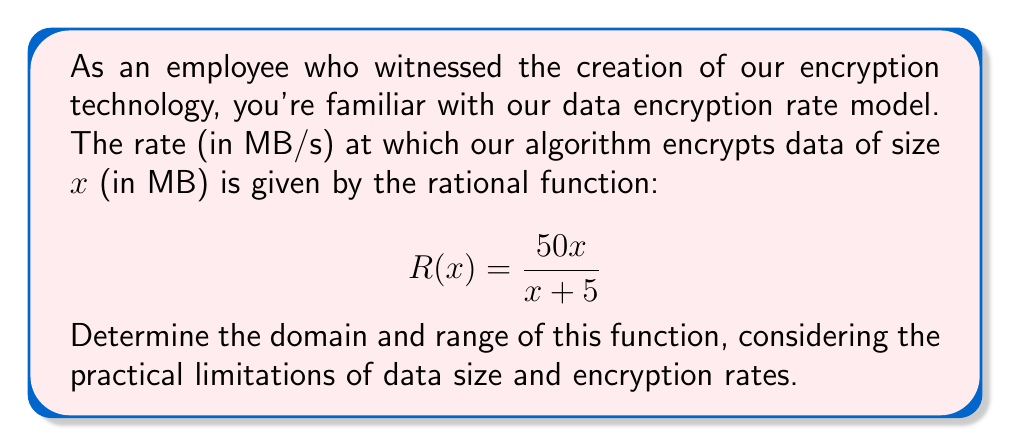Can you answer this question? Let's approach this step-by-step:

1) Domain:
   The domain is all possible input values (data sizes) for which the function is defined.
   
   - The denominator cannot be zero: $x + 5 \neq 0$
   - Solving for x: $x \neq -5$
   
   However, since x represents data size, it cannot be negative in practice.
   Therefore, $x > 0$

2) Range:
   To find the range, let's analyze the behavior of the function:

   - As $x$ approaches infinity, the function approaches a horizontal asymptote:
     $$\lim_{x \to \infty} R(x) = \lim_{x \to \infty} \frac{50x}{x + 5} = 50$$

   - When $x = 0$, $R(0) = 0$, but remember $x > 0$ in practice.
   
   - The function is always positive for positive x:
     $$R(x) = \frac{50x}{x + 5} > 0 \text{ for } x > 0$$

   - The function is strictly increasing:
     $$R'(x) = \frac{250}{(x+5)^2} > 0 \text{ for all } x > 0$$

Therefore, the range is all values from just above 0 to just below 50.

In mathematical notation: $0 < R(x) < 50$
Answer: Domain: $x > 0$
Range: $0 < R(x) < 50$ 